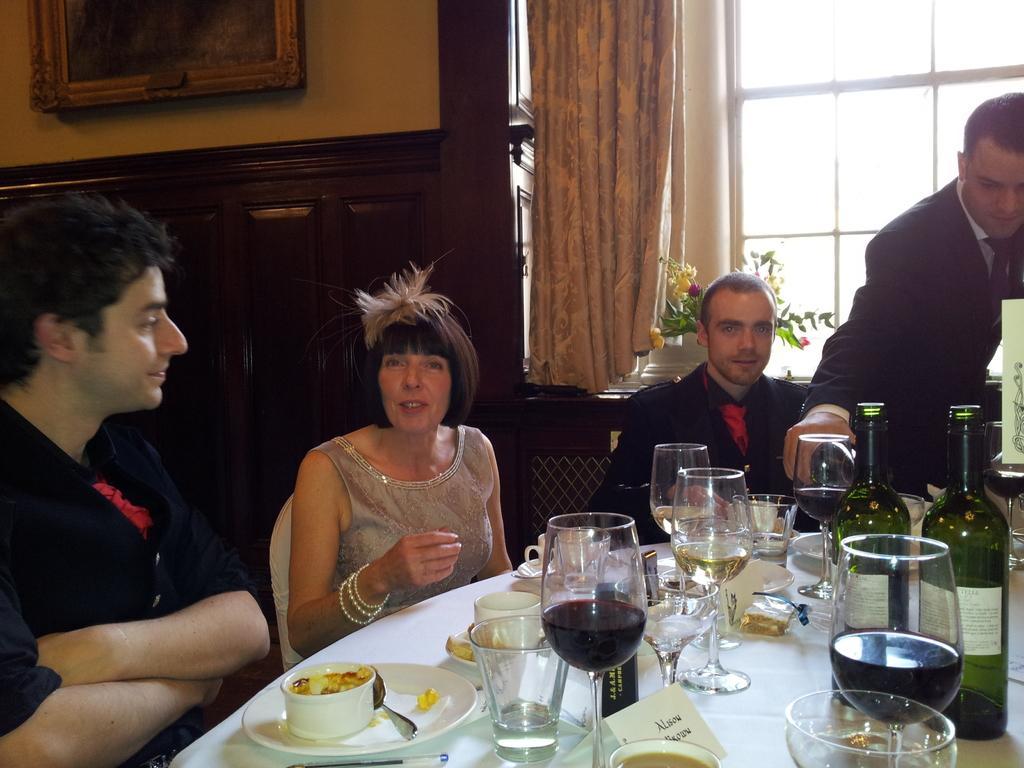In one or two sentences, can you explain what this image depicts? In this picture we can see three men and one woman sitting on chair and one is standing and in front of them there is table and on table we can see glasses, bottles, plate, spoon with some food and in background we can see window, curtains, wall with frames. 